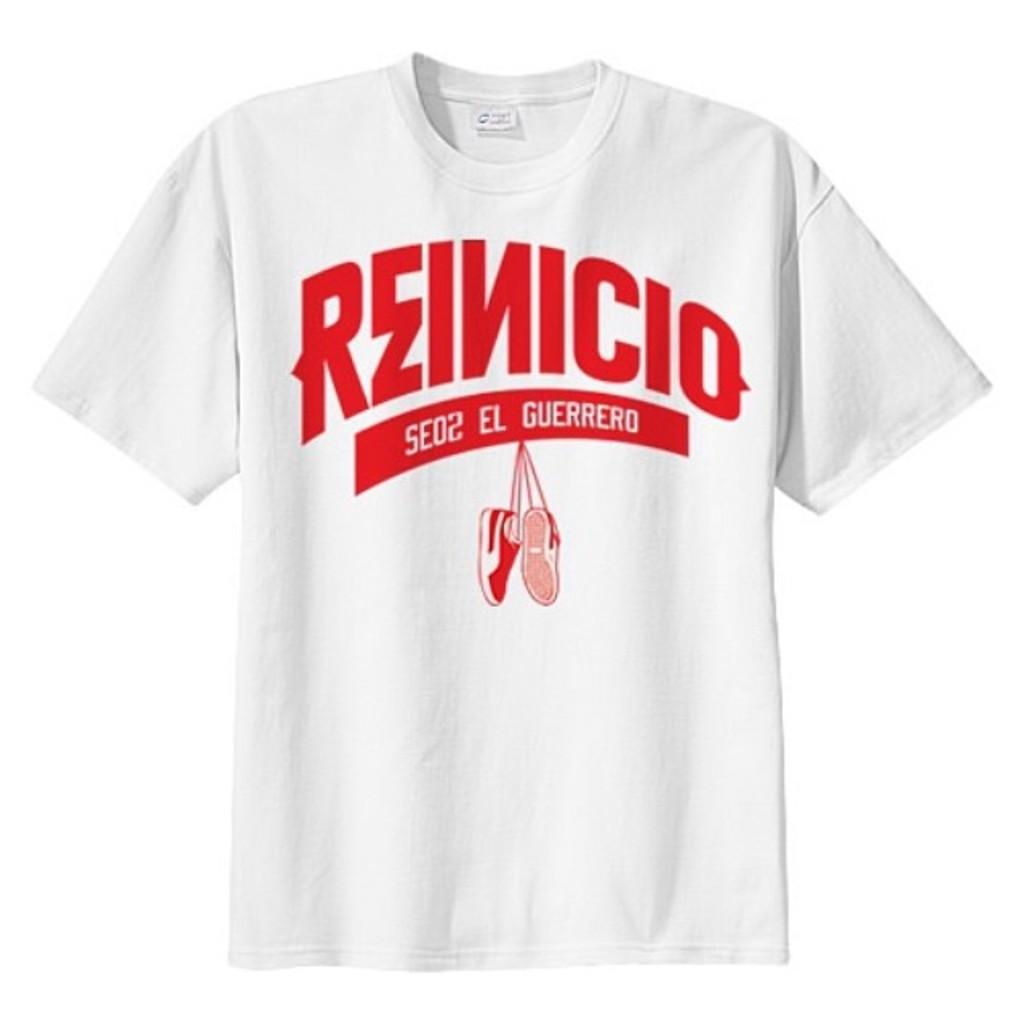<image>
Describe the image concisely. A shirt in spanish with big red letters spelling Reinicio 